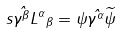<formula> <loc_0><loc_0><loc_500><loc_500>s \hat { \gamma ^ { \beta } } { L ^ { \alpha } } _ { \beta } = \psi \hat { \gamma ^ { \alpha } } \widetilde { \psi }</formula> 